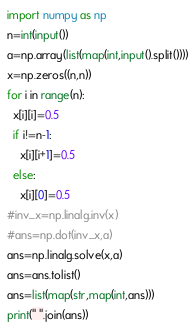<code> <loc_0><loc_0><loc_500><loc_500><_Python_>import numpy as np
n=int(input())
a=np.array(list(map(int,input().split())))
x=np.zeros((n,n))
for i in range(n):
  x[i][i]=0.5
  if i!=n-1:
    x[i][i+1]=0.5
  else:
    x[i][0]=0.5
#inv_x=np.linalg.inv(x)
#ans=np.dot(inv_x,a)
ans=np.linalg.solve(x,a)
ans=ans.tolist()
ans=list(map(str,map(int,ans)))
print(" ".join(ans))
</code> 